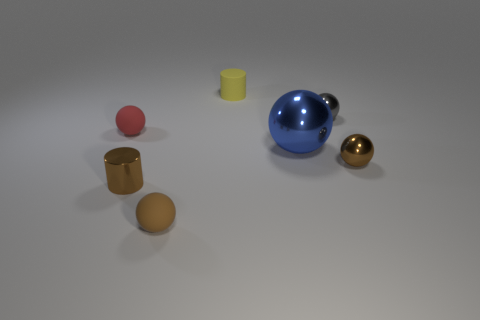Subtract all blue balls. How many balls are left? 4 Subtract all gray balls. How many balls are left? 4 Subtract 1 spheres. How many spheres are left? 4 Subtract all cyan balls. Subtract all brown blocks. How many balls are left? 5 Add 2 brown balls. How many objects exist? 9 Subtract all cylinders. How many objects are left? 5 Subtract 0 cyan cylinders. How many objects are left? 7 Subtract all big shiny balls. Subtract all yellow rubber objects. How many objects are left? 5 Add 1 brown metallic balls. How many brown metallic balls are left? 2 Add 3 tiny matte objects. How many tiny matte objects exist? 6 